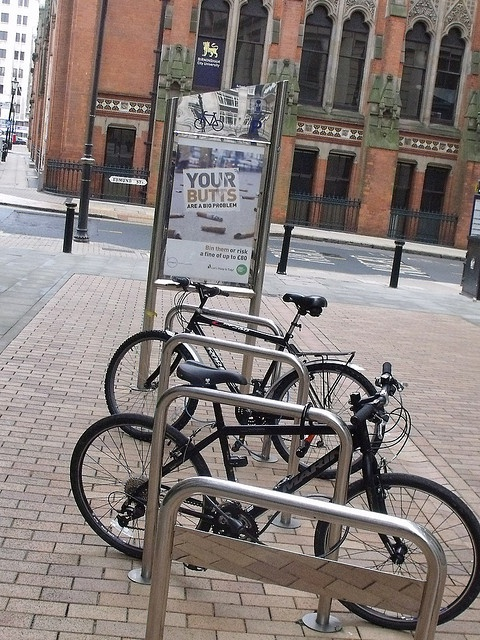Describe the objects in this image and their specific colors. I can see bicycle in white, black, darkgray, gray, and lightgray tones and bicycle in white, gray, black, darkgray, and lightgray tones in this image. 